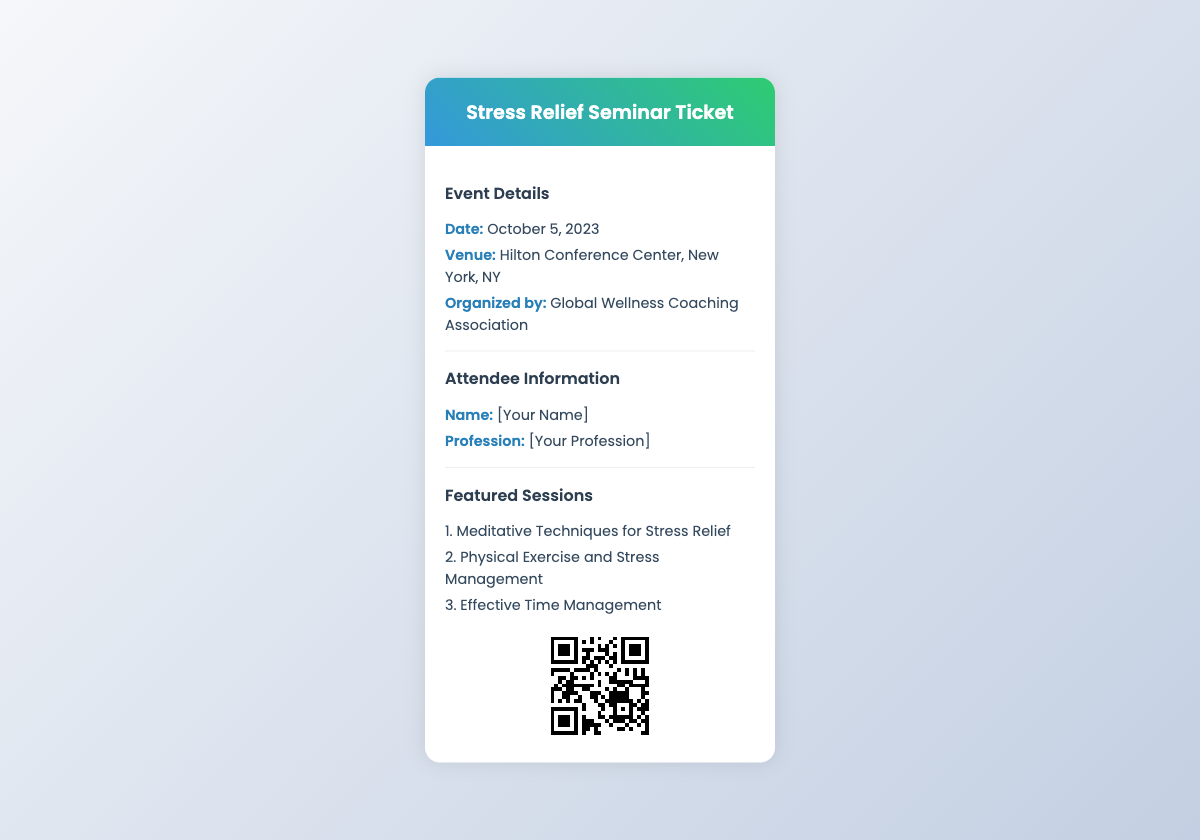what is the date of the seminar? The date of the seminar is explicitly mentioned in the event details section of the document.
Answer: October 5, 2023 where is the seminar being held? The venue for the seminar is stated in the event details section of the document.
Answer: Hilton Conference Center, New York, NY who organized the seminar? The organizer of the seminar is indicated in the event details section of the document.
Answer: Global Wellness Coaching Association what are the featured sessions in the seminar? The featured sessions are listed under the Featured Sessions section in the document.
Answer: Meditative Techniques for Stress Relief, Physical Exercise and Stress Management, Effective Time Management what is the purpose of the QR code on the ticket? The QR code serves to provide quick access to more information related to the seminar.
Answer: Access to seminar information how many featured sessions are there? The total number of featured sessions can be counted from the list provided in the document.
Answer: 3 what profession is listed for the attendee? The attendee's profession is indicated as a placeholder in the attendee information section.
Answer: [Your Profession] what type of document is this? The document is specifically a ticket for an event, providing details about attendance and participation.
Answer: Ticket 